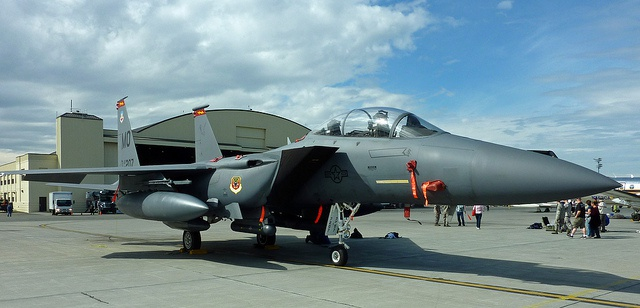Describe the objects in this image and their specific colors. I can see airplane in lightblue, black, gray, and darkgray tones, truck in lightblue, black, gray, and darkgray tones, people in lightblue, black, gray, darkgray, and tan tones, truck in lightblue, black, gray, purple, and navy tones, and people in lightblue, black, gray, maroon, and navy tones in this image. 